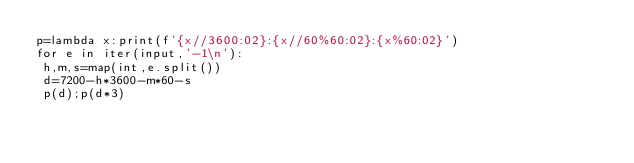Convert code to text. <code><loc_0><loc_0><loc_500><loc_500><_Python_>p=lambda x:print(f'{x//3600:02}:{x//60%60:02}:{x%60:02}')
for e in iter(input,'-1\n'):
 h,m,s=map(int,e.split())
 d=7200-h*3600-m*60-s
 p(d);p(d*3)
</code> 